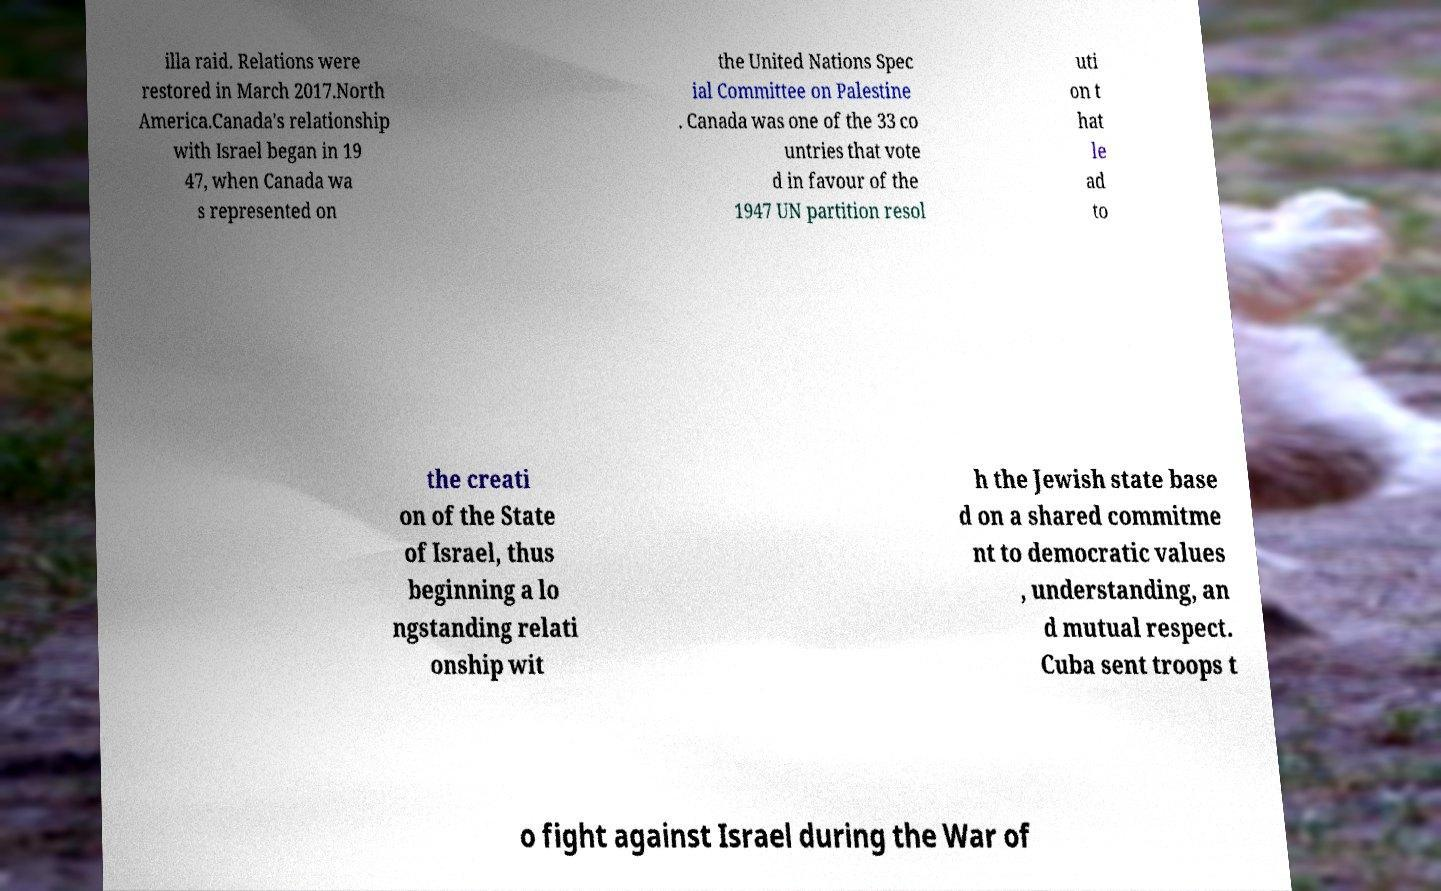There's text embedded in this image that I need extracted. Can you transcribe it verbatim? illa raid. Relations were restored in March 2017.North America.Canada's relationship with Israel began in 19 47, when Canada wa s represented on the United Nations Spec ial Committee on Palestine . Canada was one of the 33 co untries that vote d in favour of the 1947 UN partition resol uti on t hat le ad to the creati on of the State of Israel, thus beginning a lo ngstanding relati onship wit h the Jewish state base d on a shared commitme nt to democratic values , understanding, an d mutual respect. Cuba sent troops t o fight against Israel during the War of 